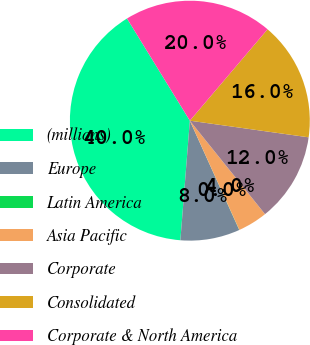Convert chart. <chart><loc_0><loc_0><loc_500><loc_500><pie_chart><fcel>(millions)<fcel>Europe<fcel>Latin America<fcel>Asia Pacific<fcel>Corporate<fcel>Consolidated<fcel>Corporate & North America<nl><fcel>39.96%<fcel>8.01%<fcel>0.02%<fcel>4.01%<fcel>12.0%<fcel>16.0%<fcel>19.99%<nl></chart> 